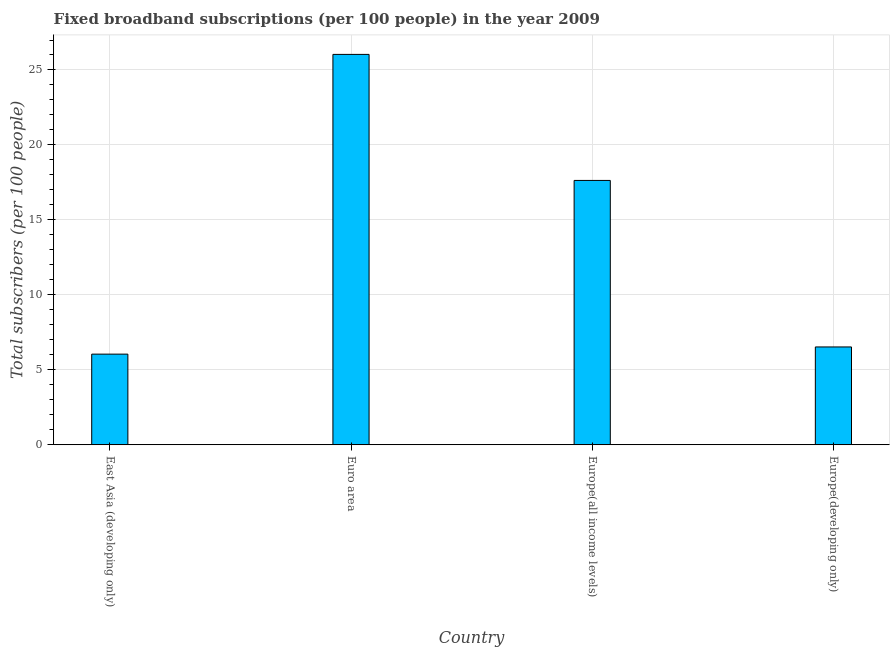What is the title of the graph?
Make the answer very short. Fixed broadband subscriptions (per 100 people) in the year 2009. What is the label or title of the Y-axis?
Your response must be concise. Total subscribers (per 100 people). What is the total number of fixed broadband subscriptions in Europe(developing only)?
Offer a terse response. 6.53. Across all countries, what is the maximum total number of fixed broadband subscriptions?
Your answer should be compact. 26.04. Across all countries, what is the minimum total number of fixed broadband subscriptions?
Give a very brief answer. 6.05. In which country was the total number of fixed broadband subscriptions minimum?
Give a very brief answer. East Asia (developing only). What is the sum of the total number of fixed broadband subscriptions?
Offer a terse response. 56.25. What is the difference between the total number of fixed broadband subscriptions in East Asia (developing only) and Euro area?
Keep it short and to the point. -19.99. What is the average total number of fixed broadband subscriptions per country?
Your answer should be compact. 14.06. What is the median total number of fixed broadband subscriptions?
Give a very brief answer. 12.08. What is the ratio of the total number of fixed broadband subscriptions in Euro area to that in Europe(all income levels)?
Ensure brevity in your answer.  1.48. Is the difference between the total number of fixed broadband subscriptions in East Asia (developing only) and Euro area greater than the difference between any two countries?
Your answer should be very brief. Yes. What is the difference between the highest and the second highest total number of fixed broadband subscriptions?
Ensure brevity in your answer.  8.41. What is the difference between the highest and the lowest total number of fixed broadband subscriptions?
Ensure brevity in your answer.  19.99. In how many countries, is the total number of fixed broadband subscriptions greater than the average total number of fixed broadband subscriptions taken over all countries?
Give a very brief answer. 2. How many bars are there?
Offer a terse response. 4. Are all the bars in the graph horizontal?
Provide a succinct answer. No. What is the difference between two consecutive major ticks on the Y-axis?
Provide a short and direct response. 5. What is the Total subscribers (per 100 people) in East Asia (developing only)?
Provide a succinct answer. 6.05. What is the Total subscribers (per 100 people) in Euro area?
Provide a succinct answer. 26.04. What is the Total subscribers (per 100 people) in Europe(all income levels)?
Offer a terse response. 17.63. What is the Total subscribers (per 100 people) in Europe(developing only)?
Make the answer very short. 6.53. What is the difference between the Total subscribers (per 100 people) in East Asia (developing only) and Euro area?
Keep it short and to the point. -19.99. What is the difference between the Total subscribers (per 100 people) in East Asia (developing only) and Europe(all income levels)?
Offer a terse response. -11.59. What is the difference between the Total subscribers (per 100 people) in East Asia (developing only) and Europe(developing only)?
Your answer should be very brief. -0.48. What is the difference between the Total subscribers (per 100 people) in Euro area and Europe(all income levels)?
Your answer should be very brief. 8.41. What is the difference between the Total subscribers (per 100 people) in Euro area and Europe(developing only)?
Provide a short and direct response. 19.51. What is the difference between the Total subscribers (per 100 people) in Europe(all income levels) and Europe(developing only)?
Make the answer very short. 11.11. What is the ratio of the Total subscribers (per 100 people) in East Asia (developing only) to that in Euro area?
Provide a succinct answer. 0.23. What is the ratio of the Total subscribers (per 100 people) in East Asia (developing only) to that in Europe(all income levels)?
Your response must be concise. 0.34. What is the ratio of the Total subscribers (per 100 people) in East Asia (developing only) to that in Europe(developing only)?
Your answer should be compact. 0.93. What is the ratio of the Total subscribers (per 100 people) in Euro area to that in Europe(all income levels)?
Ensure brevity in your answer.  1.48. What is the ratio of the Total subscribers (per 100 people) in Euro area to that in Europe(developing only)?
Make the answer very short. 3.99. What is the ratio of the Total subscribers (per 100 people) in Europe(all income levels) to that in Europe(developing only)?
Your answer should be compact. 2.7. 